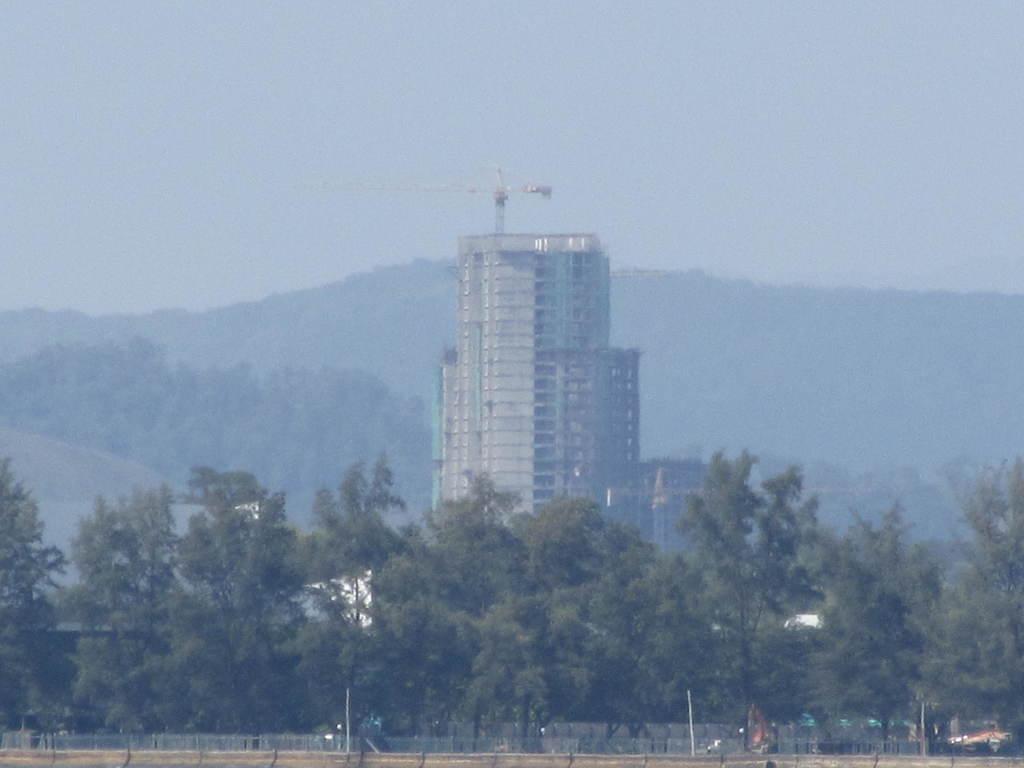Please provide a concise description of this image. In the foreground of this picture, there are trees and the fencing and in the background, there is a building, mountain and the sky. 